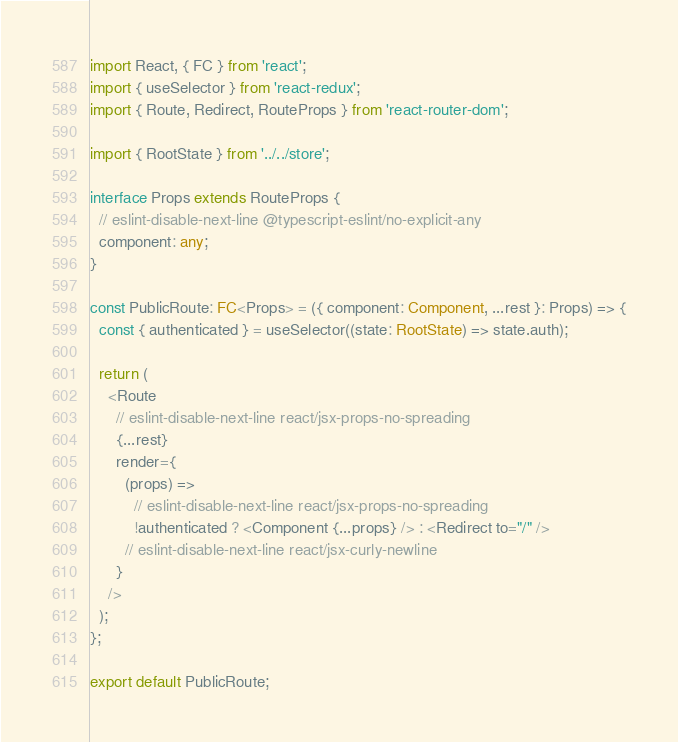Convert code to text. <code><loc_0><loc_0><loc_500><loc_500><_TypeScript_>import React, { FC } from 'react';
import { useSelector } from 'react-redux';
import { Route, Redirect, RouteProps } from 'react-router-dom';

import { RootState } from '../../store';

interface Props extends RouteProps {
  // eslint-disable-next-line @typescript-eslint/no-explicit-any
  component: any;
}

const PublicRoute: FC<Props> = ({ component: Component, ...rest }: Props) => {
  const { authenticated } = useSelector((state: RootState) => state.auth);

  return (
    <Route
      // eslint-disable-next-line react/jsx-props-no-spreading
      {...rest}
      render={
        (props) =>
          // eslint-disable-next-line react/jsx-props-no-spreading
          !authenticated ? <Component {...props} /> : <Redirect to="/" />
        // eslint-disable-next-line react/jsx-curly-newline
      }
    />
  );
};

export default PublicRoute;
</code> 